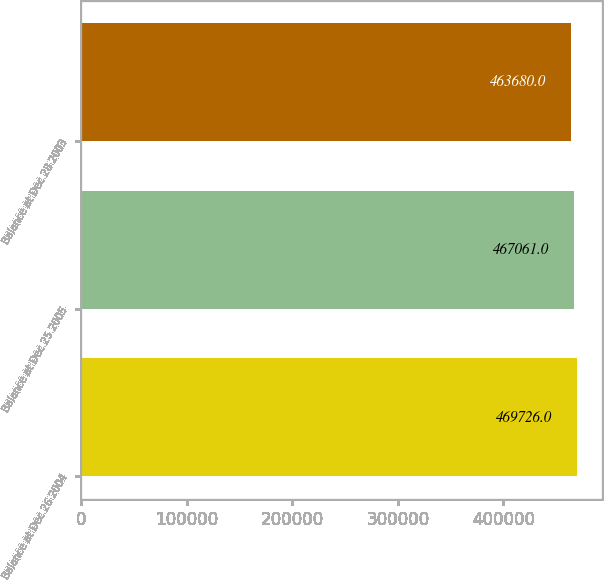<chart> <loc_0><loc_0><loc_500><loc_500><bar_chart><fcel>Balance at Dec 26 2004<fcel>Balance at Dec 25 2005<fcel>Balance at Dec 28 2003<nl><fcel>469726<fcel>467061<fcel>463680<nl></chart> 